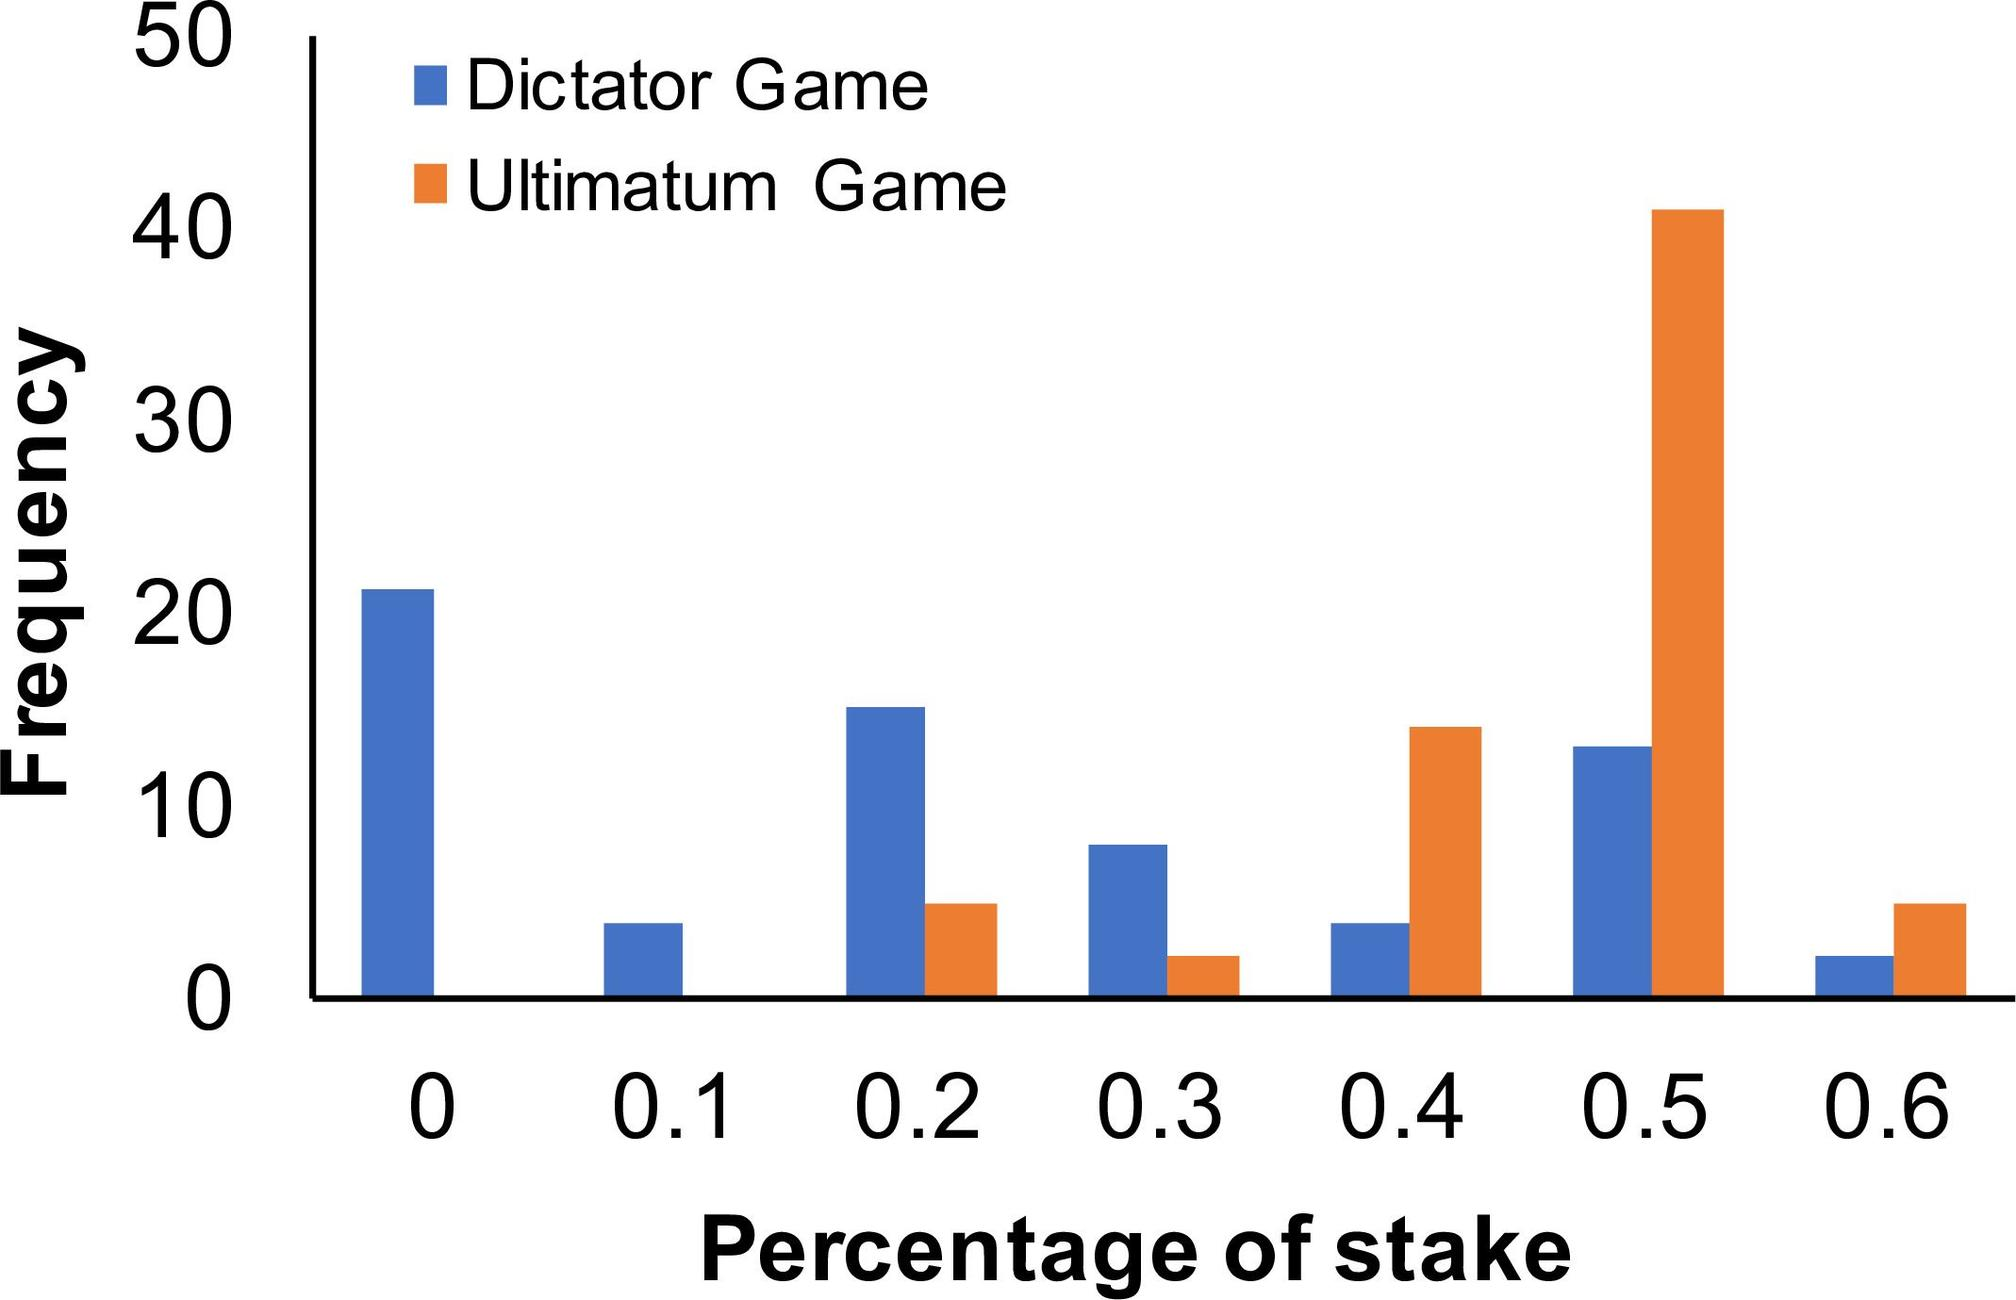Based on the data, which game demonstrates a higher frequency of offers at the 0.5 stake level? A. Dictator Game B. Ultimatum Game C. Both games show the same frequency D. The data does not specify frequencies at the 0.5 stake level The bar graph clearly shows that the Ultimatum Game has a higher frequency bar at the 0.5 stake level compared to the Dictator Game. Therefore, the correct answer is B. Ultimatum Game. 